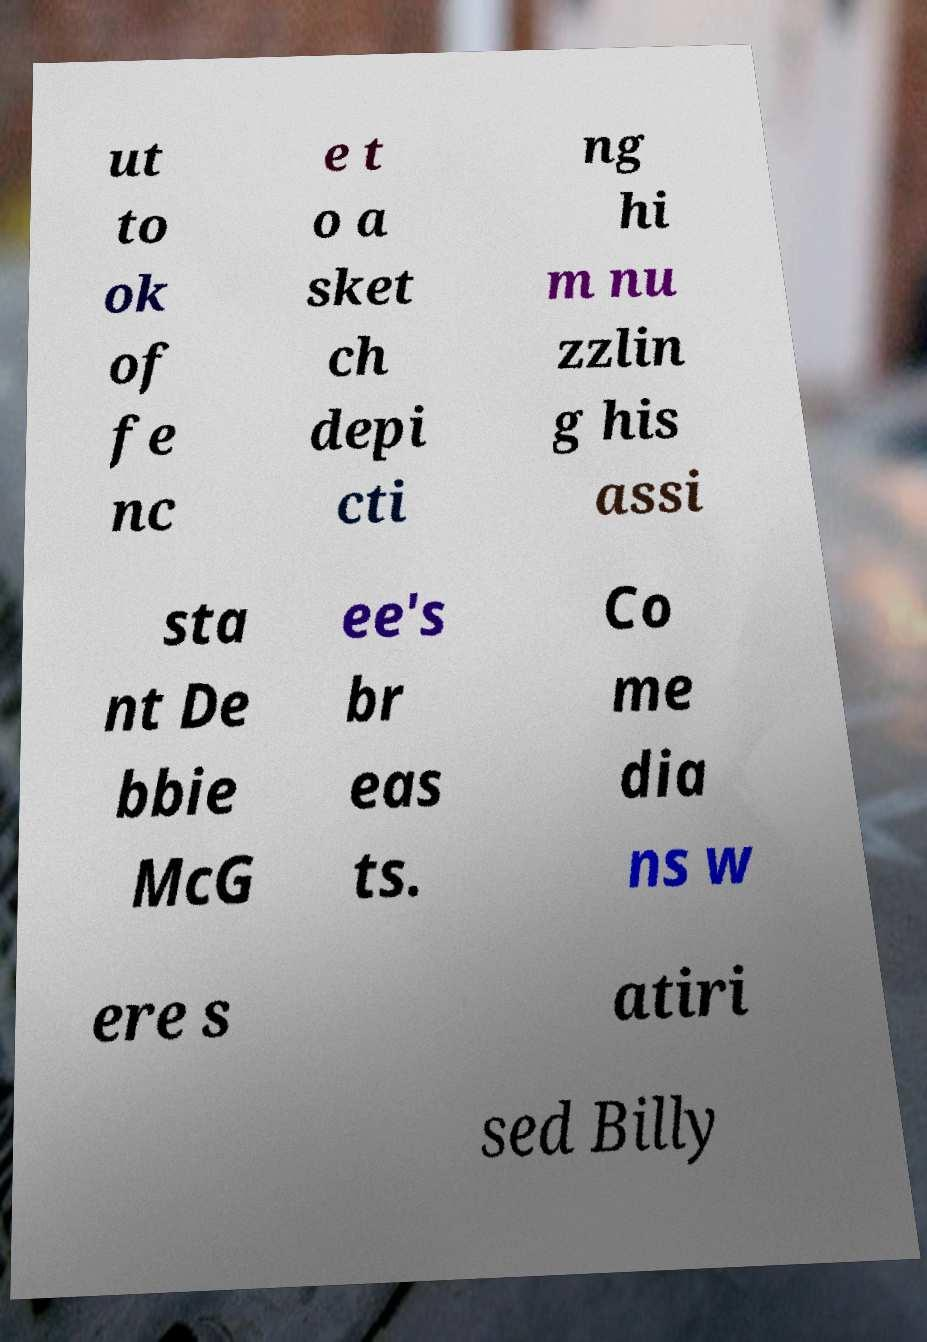Could you extract and type out the text from this image? ut to ok of fe nc e t o a sket ch depi cti ng hi m nu zzlin g his assi sta nt De bbie McG ee's br eas ts. Co me dia ns w ere s atiri sed Billy 